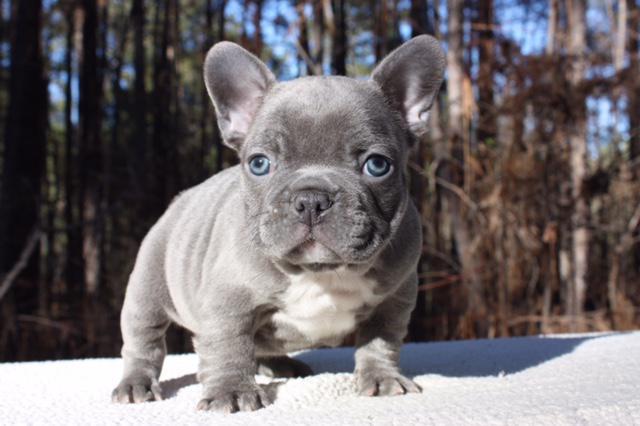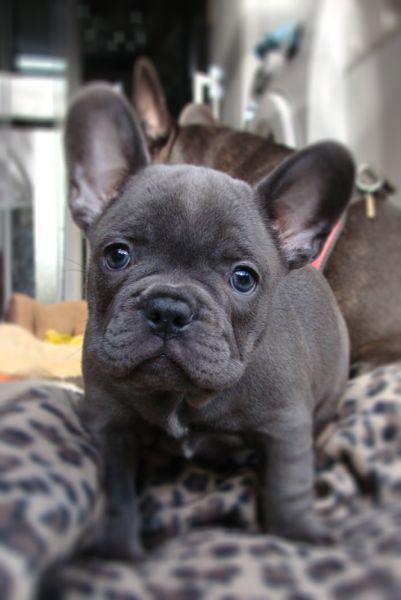The first image is the image on the left, the second image is the image on the right. Given the left and right images, does the statement "The left image features a dark big-eared puppy reclining on its belly with both paws forward and visible, with its body turned forward and its eyes glancing sideways." hold true? Answer yes or no. No. The first image is the image on the left, the second image is the image on the right. Evaluate the accuracy of this statement regarding the images: "The dog in the image on the left is lying down.". Is it true? Answer yes or no. No. 